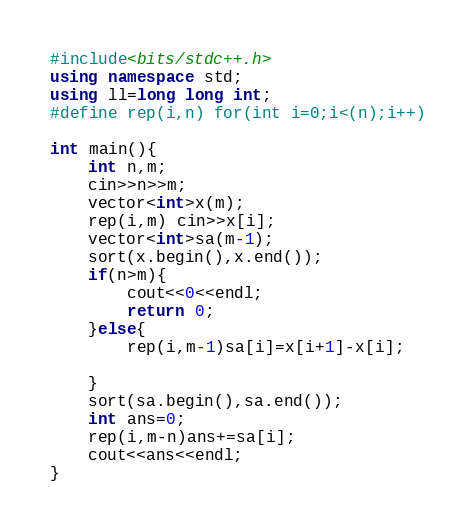<code> <loc_0><loc_0><loc_500><loc_500><_C++_>#include<bits/stdc++.h>
using namespace std;
using ll=long long int;
#define rep(i,n) for(int i=0;i<(n);i++)

int main(){
    int n,m;
    cin>>n>>m;
    vector<int>x(m);
    rep(i,m) cin>>x[i];
    vector<int>sa(m-1);
    sort(x.begin(),x.end());
    if(n>m){
        cout<<0<<endl;
        return 0;
    }else{
        rep(i,m-1)sa[i]=x[i+1]-x[i];

    }
    sort(sa.begin(),sa.end());
    int ans=0;
    rep(i,m-n)ans+=sa[i];
    cout<<ans<<endl;
}</code> 